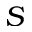<formula> <loc_0><loc_0><loc_500><loc_500>S</formula> 